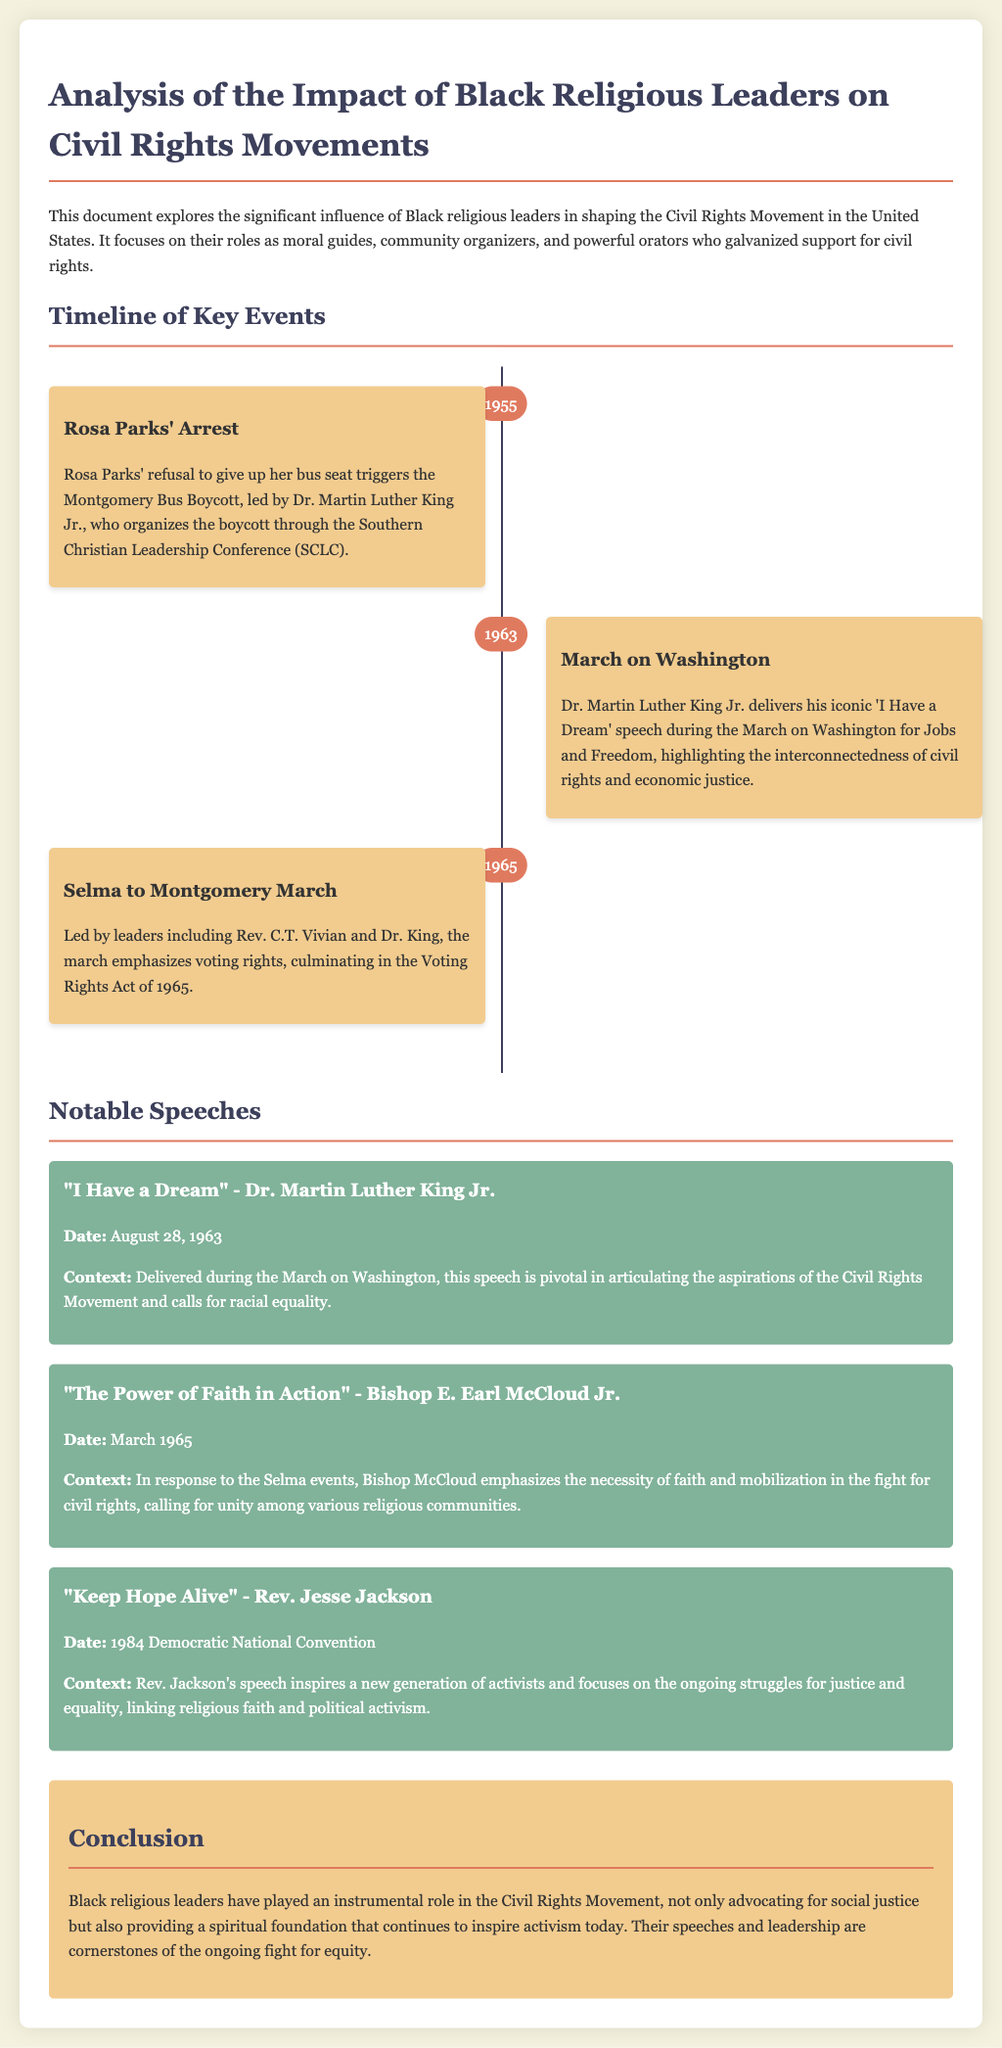What year did Rosa Parks' arrest occur? The timeline indicates that Rosa Parks' arrest occurred in 1955.
Answer: 1955 Who delivered the "I Have a Dream" speech? The notable speeches section states that Dr. Martin Luther King Jr. delivered the "I Have a Dream" speech.
Answer: Dr. Martin Luther King Jr What major event is highlighted for the year 1965? The timeline mentions the Selma to Montgomery March as the significant event for 1965.
Answer: Selma to Montgomery March In which speech does Bishop E. Earl McCloud Jr. emphasize faith and mobilization? The notable speeches section specifies that Bishop E. Earl McCloud Jr. delivered the speech titled "The Power of Faith in Action".
Answer: The Power of Faith in Action How many years after the Montgomery Bus Boycott did the March on Washington occur? The document states that the Montgomery Bus Boycott occurred in 1955 and the March on Washington in 1963, which is 8 years later.
Answer: 8 years What is the primary theme of Rev. Jesse Jackson's speech at the 1984 Democratic National Convention? The context of Rev. Jesse Jackson's speech highlights the ongoing struggles for justice and equality linking religious faith and political activism.
Answer: Justice and equality What color indicates the timeline items in the document? The timeline items are described as having a background of a specific color.
Answer: Beige What type of leaders does the document primarily focus on? The document details the influence of Black religious leaders in the Civil Rights Movement.
Answer: Black religious leaders 